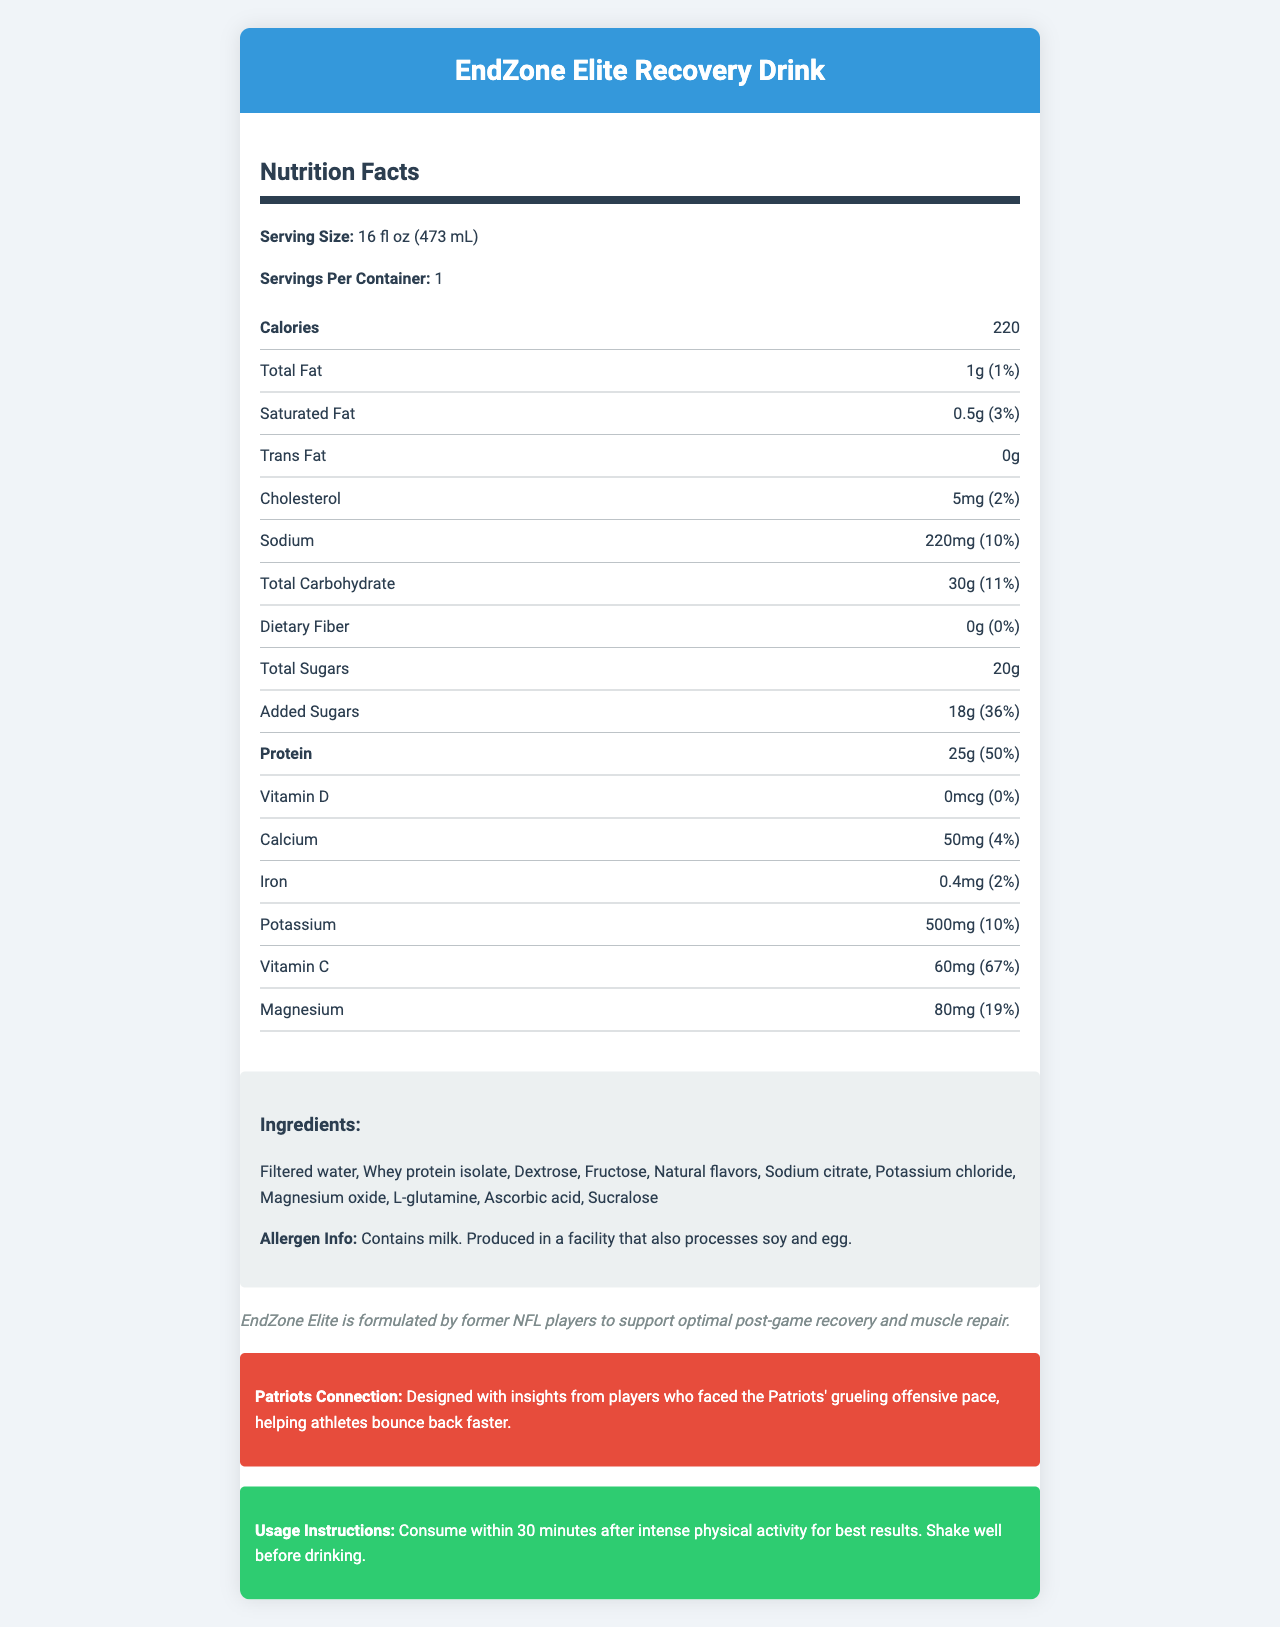what is the serving size? The serving size is specified as "16 fl oz (473 mL)" at the top of the nutrition facts section.
Answer: 16 fl oz (473 mL) how many grams of protein does the drink contain? The amount of protein is listed as "25g" in the nutrition facts.
Answer: 25g what is the daily value percentage for sodium? The daily value percentage for sodium is stated as "10%" next to the sodium content.
Answer: 10% how many calories are in one serving? The number of calories per serving is listed as "220" under the calories section.
Answer: 220 which vitamin has the highest daily value percentage? Vitamin C has the highest daily value percentage at "67%".
Answer: Vitamin C how many grams of total sugars are in the drink? The total amount of sugars in the drink is "20g".
Answer: 20g what minerals are included in the nutrition facts? The minerals listed in the nutrition facts are Calcium, Iron, Potassium, and Magnesium.
Answer: Calcium, Iron, Potassium, Magnesium what allergens does the drink contain? The allergen information states that the drink contains milk.
Answer: Milk what is the main purpose of the EndZone Elite Recovery Drink? The brand statement mentions that the drink is formulated to support optimal post-game recovery and muscle repair.
Answer: To support optimal post-game recovery and muscle repair how should the drink be consumed for best results? The usage instructions recommend consuming the drink within 30 minutes after intense physical activity for best results.
Answer: Within 30 minutes after intense physical activity which ingredient provides the protein content in the drink? Whey protein isolate is listed as an ingredient, and it is the source of protein in the drink.
Answer: Whey protein isolate what is the daily value percentage for magnesium? A. 10% B. 15% C. 19% D. 25% The daily value percentage for magnesium is "19%", as stated in the nutrition facts.
Answer: C. 19% how many grams of saturated fat does the drink contain? A. 1g B. 0.5g C. 2g D. 3g The amount of saturated fat in the drink is listed as "0.5g".
Answer: B. 0.5g is there any information about fiber content in the drink? The nutrition facts indicate that the drink contains "0g" of dietary fiber.
Answer: Yes does the drink contain any added sugars? The nutrition facts list "added sugars" as "18g".
Answer: Yes can determine the exact production location of the drink? The document does not provide information about the exact production location of the drink.
Answer: Not enough information summarize the primary information about the EndZone Elite Recovery Drink. The document provides detailed nutrition facts, ingredients, allergen information, brand statement, connection to the Patriots, and usage instructions for the drink.
Answer: A high-protein sports drink called EndZone Elite Recovery Drink offers 220 calories per serving, with 25g of protein, 30g of carbohydrates, and 1g of fat. It includes key ingredients like whey protein isolate and is designed to aid post-game recovery and muscle repair. The drink should be consumed within 30 minutes after intense physical activity. The nutrition facts also highlight significant vitamin and mineral content, including high levels of Vitamin C. 